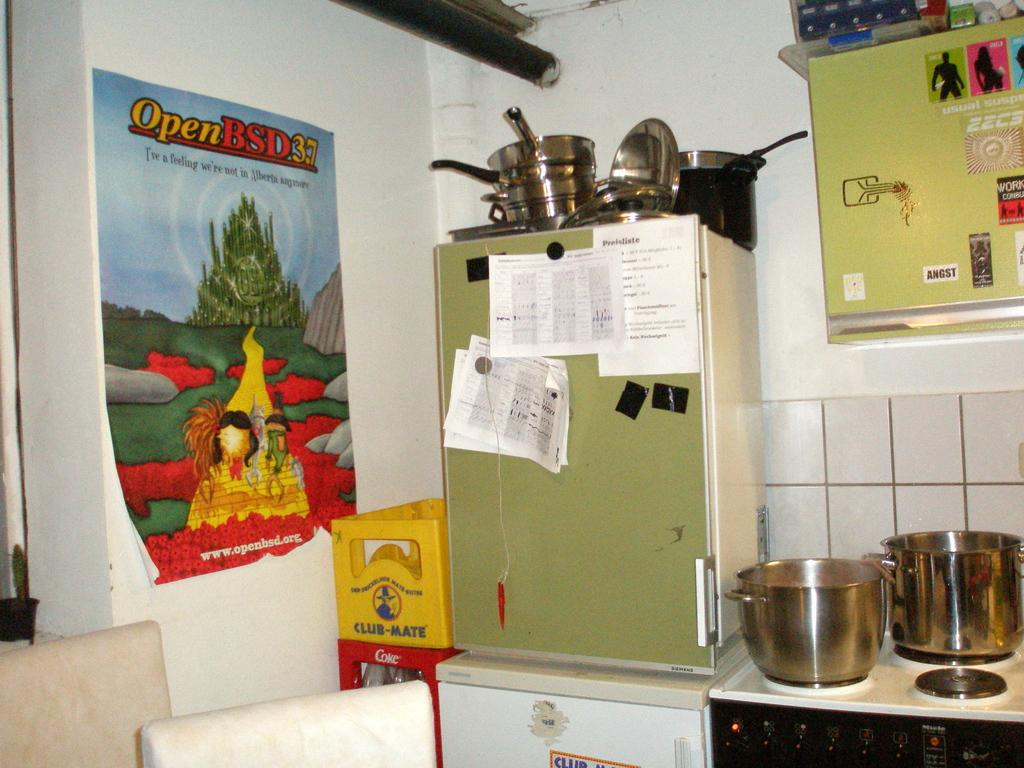<image>
Relay a brief, clear account of the picture shown. a poster on a kitchen wall that says 'open bsd' on it 